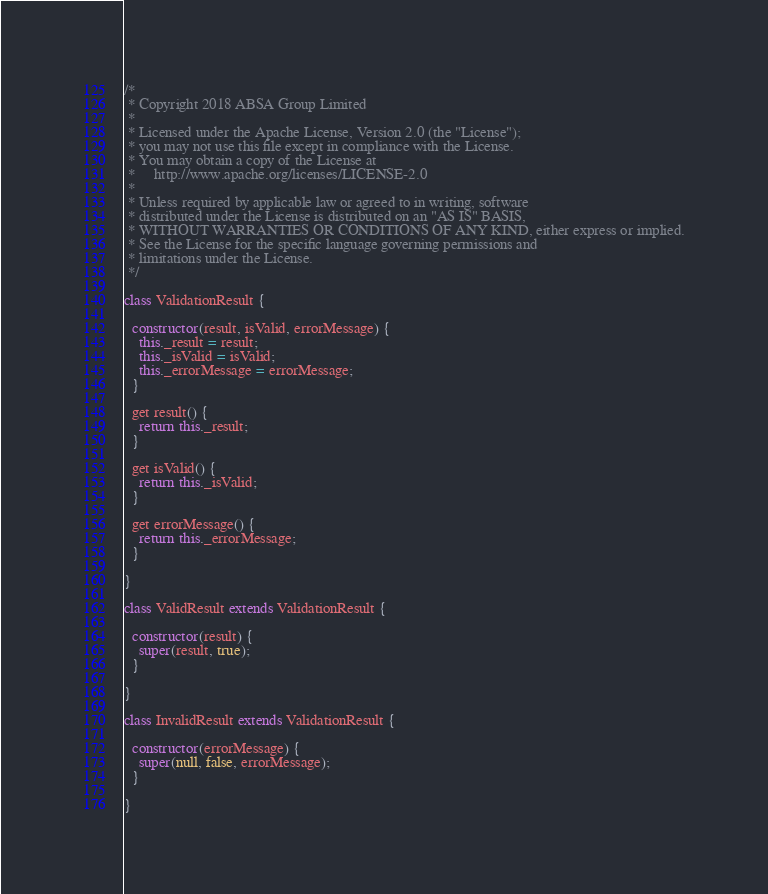Convert code to text. <code><loc_0><loc_0><loc_500><loc_500><_JavaScript_>/*
 * Copyright 2018 ABSA Group Limited
 *
 * Licensed under the Apache License, Version 2.0 (the "License");
 * you may not use this file except in compliance with the License.
 * You may obtain a copy of the License at
 *     http://www.apache.org/licenses/LICENSE-2.0
 *
 * Unless required by applicable law or agreed to in writing, software
 * distributed under the License is distributed on an "AS IS" BASIS,
 * WITHOUT WARRANTIES OR CONDITIONS OF ANY KIND, either express or implied.
 * See the License for the specific language governing permissions and
 * limitations under the License.
 */

class ValidationResult {

  constructor(result, isValid, errorMessage) {
    this._result = result;
    this._isValid = isValid;
    this._errorMessage = errorMessage;
  }

  get result() {
    return this._result;
  }

  get isValid() {
    return this._isValid;
  }

  get errorMessage() {
    return this._errorMessage;
  }

}

class ValidResult extends ValidationResult {

  constructor(result) {
    super(result, true);
  }

}

class InvalidResult extends ValidationResult {

  constructor(errorMessage) {
    super(null, false, errorMessage);
  }

}
</code> 